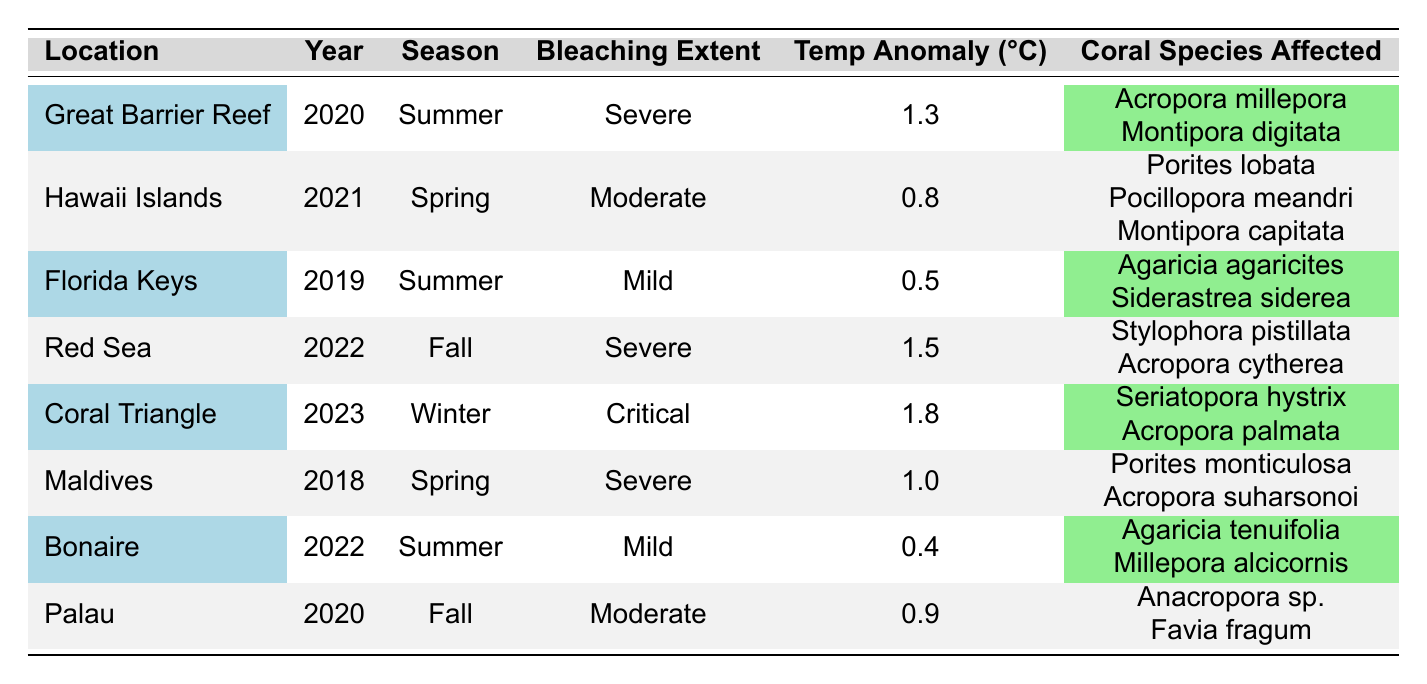What location experienced the most severe coral bleaching event? The table lists multiple locations and their corresponding bleaching extents. Looking for "Severe" bleaching, the Great Barrier Reef and the Red Sea both report this extent, but the Red Sea has a higher temperature anomaly of 1.5 °C compared to 1.3 °C for the Great Barrier Reef.
Answer: Red Sea What was the average temperature anomaly for coral bleaching events in 2022? The table shows two events for 2022: the Red Sea with a 1.5 °C anomaly and Bonaire with a 0.4 °C anomaly. The average is calculated as (1.5 + 0.4) / 2 = 0.95 °C.
Answer: 0.95 °C Did the Coral Triangle experience a bleaching event in the summer season? The data shows that the Coral Triangle had a bleaching event in winter, not summer. This is confirmed by reviewing the season for Coral Triangle, which is recorded as "Winter."
Answer: No Which year had the most recent bleaching event, and what was the extent? The most recent year listed is 2023, and it corresponds to the Coral Triangle with a bleaching extent described as "Critical."
Answer: 2023, Critical How many different coral species were affected in the Hawaii Islands in 2021? In 2021, the Hawaii Islands reported three coral species affected: Porites lobata, Pocillopora meandri, and Montipora capitata. Counting these gives a total of three species.
Answer: 3 What is the difference in temperature anomalies between the most severe and the mildest bleaching events? The most severe event has a temperature anomaly of 1.8 °C in the Coral Triangle, while the mildest (Bonaire) has an anomaly of 0.4 °C. The difference is 1.8 - 0.4 = 1.4 °C.
Answer: 1.4 °C Which season had the highest average bleaching extent based on the data provided? To determine this, we need to assign numeric values to the bleaching extents: Mild = 1, Moderate = 2, Severe = 3, Critical = 4. For summer (2 events: 3 + 1), spring (2 events: 2 + 3), fall (2 events: 3 + 2), and winter (1 event: 4), we find summer has (4/2 = 2), spring (5/2 = 2.5), fall (5/2 = 2.5), winter (4). Hence, spring and fall tie as having the highest average at 2.5.
Answer: Spring and Fall Was there a bleaching event in the Florida Keys in 2020, and what was its extent? The Florida Keys event is recorded for 2019, not 2020. Therefore, it does not correspond to 2020, and its extent in 2019 is "Mild."
Answer: No, Mild in 2019 